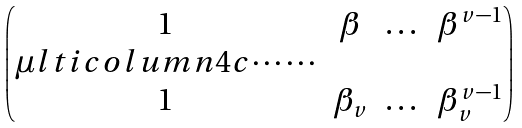<formula> <loc_0><loc_0><loc_500><loc_500>\begin{pmatrix} 1 & \beta & \dots & \beta ^ { v - 1 } \\ \mu l t i c o l u m n { 4 } { c } { \cdots \cdots } \\ 1 & \beta _ { v } & \dots & \beta _ { v } ^ { v - 1 } \\ \end{pmatrix}</formula> 